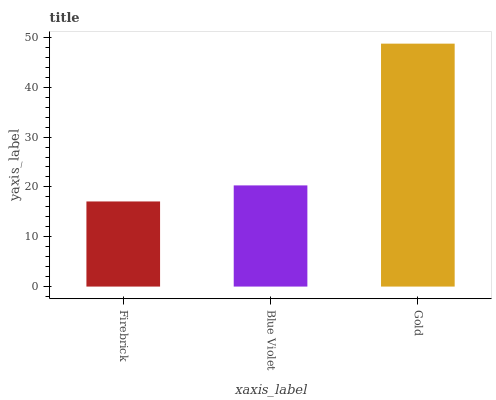Is Firebrick the minimum?
Answer yes or no. Yes. Is Gold the maximum?
Answer yes or no. Yes. Is Blue Violet the minimum?
Answer yes or no. No. Is Blue Violet the maximum?
Answer yes or no. No. Is Blue Violet greater than Firebrick?
Answer yes or no. Yes. Is Firebrick less than Blue Violet?
Answer yes or no. Yes. Is Firebrick greater than Blue Violet?
Answer yes or no. No. Is Blue Violet less than Firebrick?
Answer yes or no. No. Is Blue Violet the high median?
Answer yes or no. Yes. Is Blue Violet the low median?
Answer yes or no. Yes. Is Firebrick the high median?
Answer yes or no. No. Is Firebrick the low median?
Answer yes or no. No. 